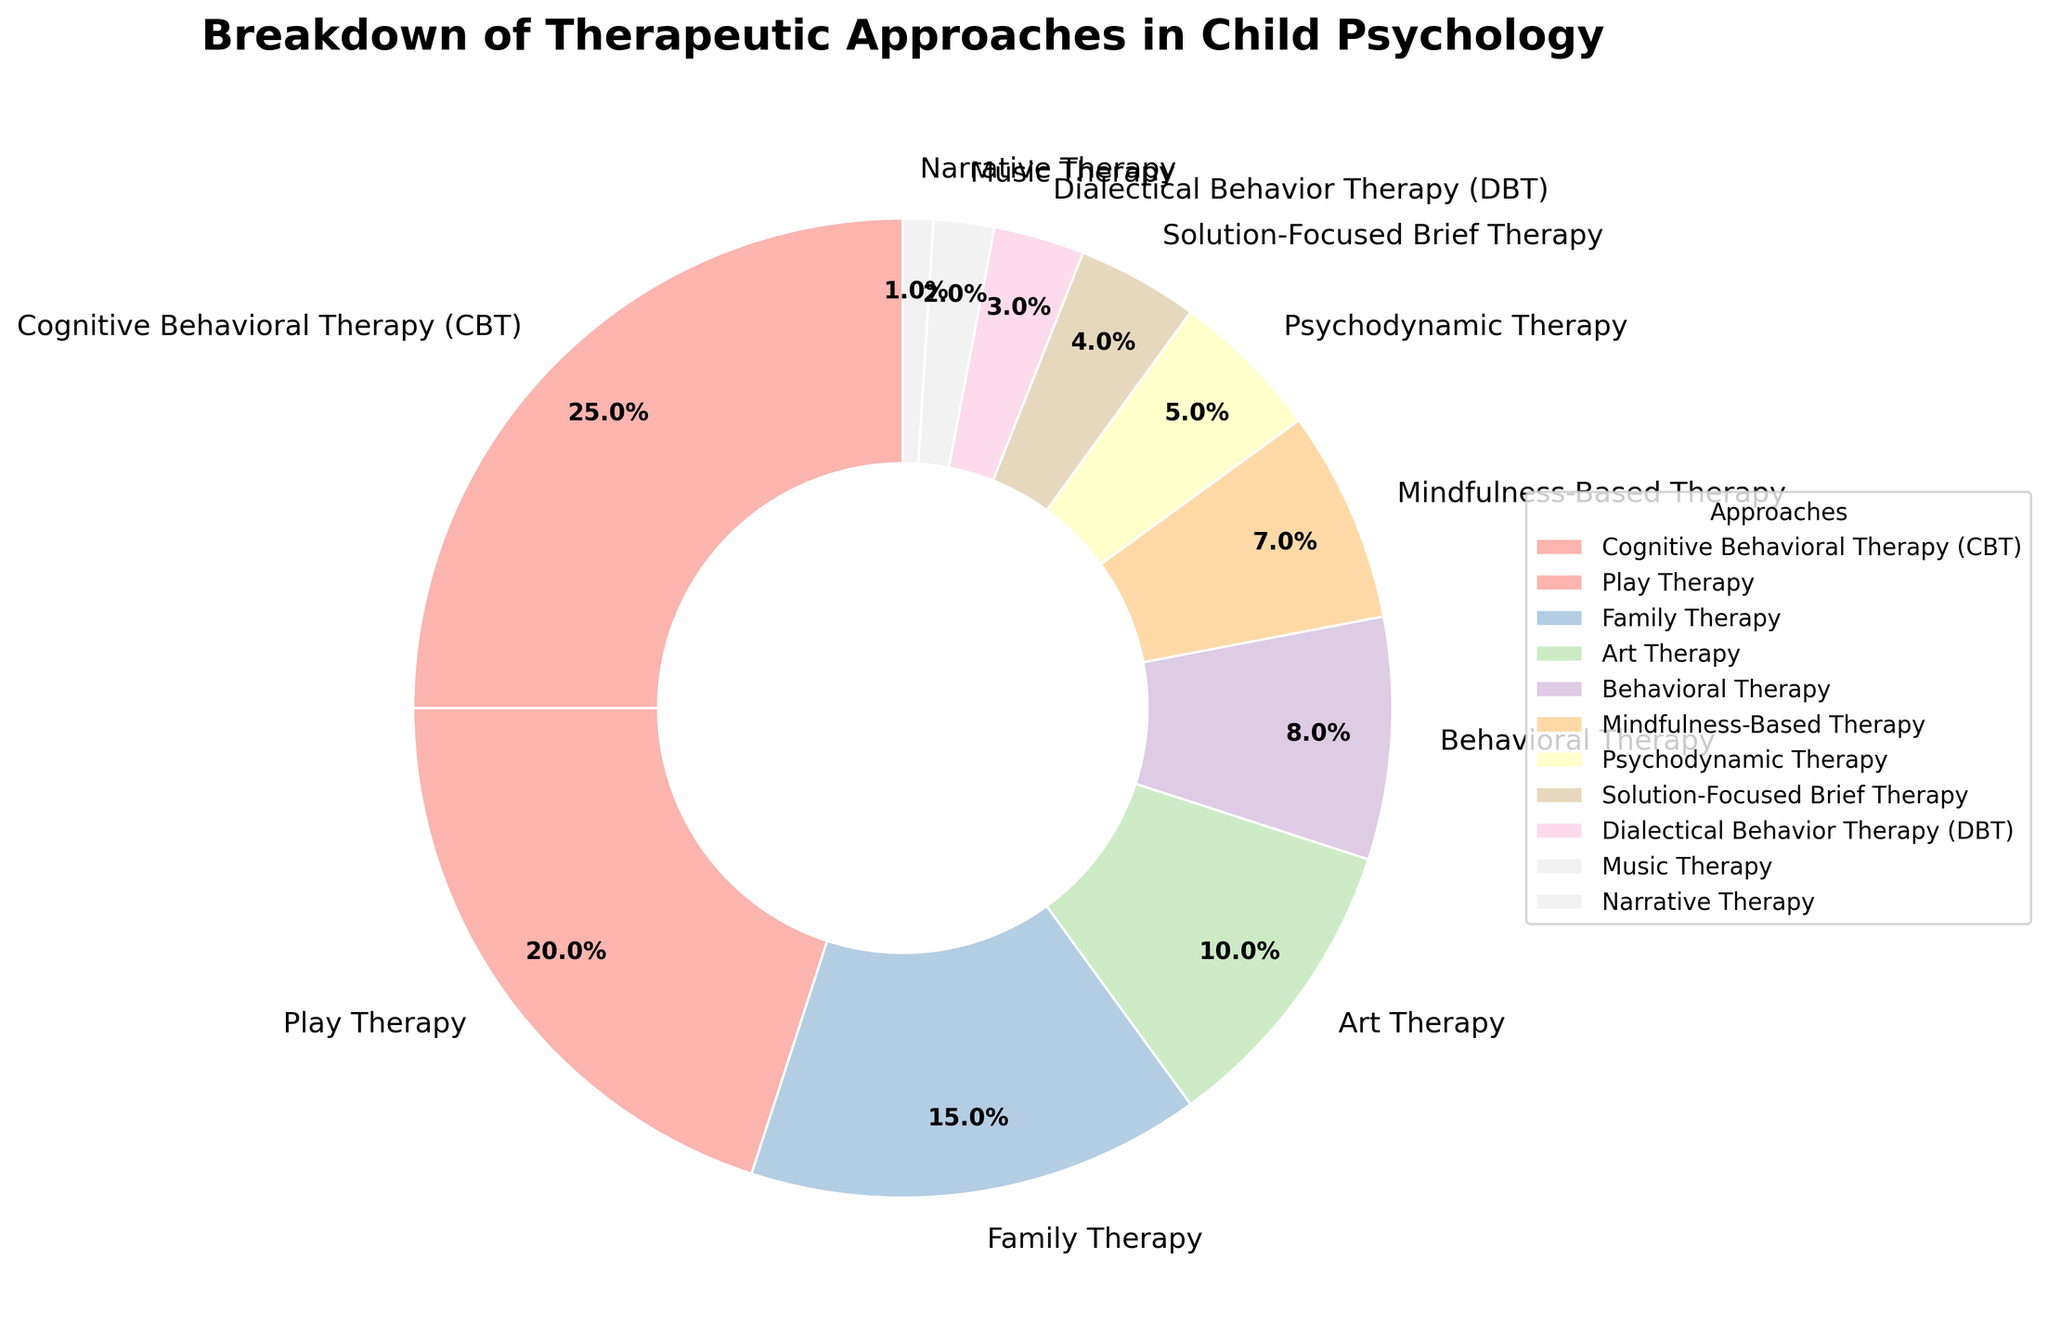What's the most widely used therapeutic approach in child psychology? The figure shows the percentage breakdown of each therapeutic approach. By examining the chart, the largest section corresponds to Cognitive Behavioral Therapy (CBT), which covers 25% of the total.
Answer: Cognitive Behavioral Therapy (CBT) How much more prevalent is Family Therapy compared to Solution-Focused Brief Therapy? The chart shows Family Therapy at 15% and Solution-Focused Brief Therapy at 4%. Subtracting 4 from 15 gives the difference.
Answer: 11% Which therapeutic approach has the smallest application in child psychology? By looking at the chart, the smallest wedge corresponds to Narrative Therapy with 1%.
Answer: Narrative Therapy What is the combined percentage of Behavioral Therapy and Mindfulness-Based Therapy? Adding the percentages of Behavioral Therapy (8%) and Mindfulness-Based Therapy (7%) gives a total of 15%.
Answer: 15% What is the difference in percentage between Play Therapy and Art Therapy? Play Therapy has 20% while Art Therapy has 10%. The difference is 20 minus 10.
Answer: 10% Which two therapeutic approaches are used equally? Examining the wedges and their percentages reveals that no two approaches are equal. Each has a unique percentage.
Answer: None Do Cognitive Behavioral Therapy (CBT) and Play Therapy together constitute more than 40% of the total approaches? Adding 25% for CBT and 20% for Play Therapy results in 45%, which is indeed more than 40%.
Answer: Yes Which approach occupies the second largest percentage after CBT? Play Therapy has the second largest percentage at 20%, following CBT at 25%.
Answer: Play Therapy Are there more memberships for Family Therapy, Art Therapy, and Behavioral Therapy combined than for CBT and Play Therapy combined? Summing Family Therapy (15%), Art Therapy (10%), and Behavioral Therapy (8%) gives 33%. Summing CBT (25%) and Play Therapy (20%) gives 45%. Thus, CBT and Play Therapy combined are more.
Answer: No What's the total percentage for approaches that have a single-digit representation (less than 10%)? Adding Behavioral Therapy (8%), Mindfulness-Based Therapy (7%), Psychodynamic Therapy (5%), Solution-Focused Brief Therapy (4%), Dialectical Behavior Therapy (DBT) (3%), Music Therapy (2%), and Narrative Therapy (1%) gives 30%.
Answer: 30% 